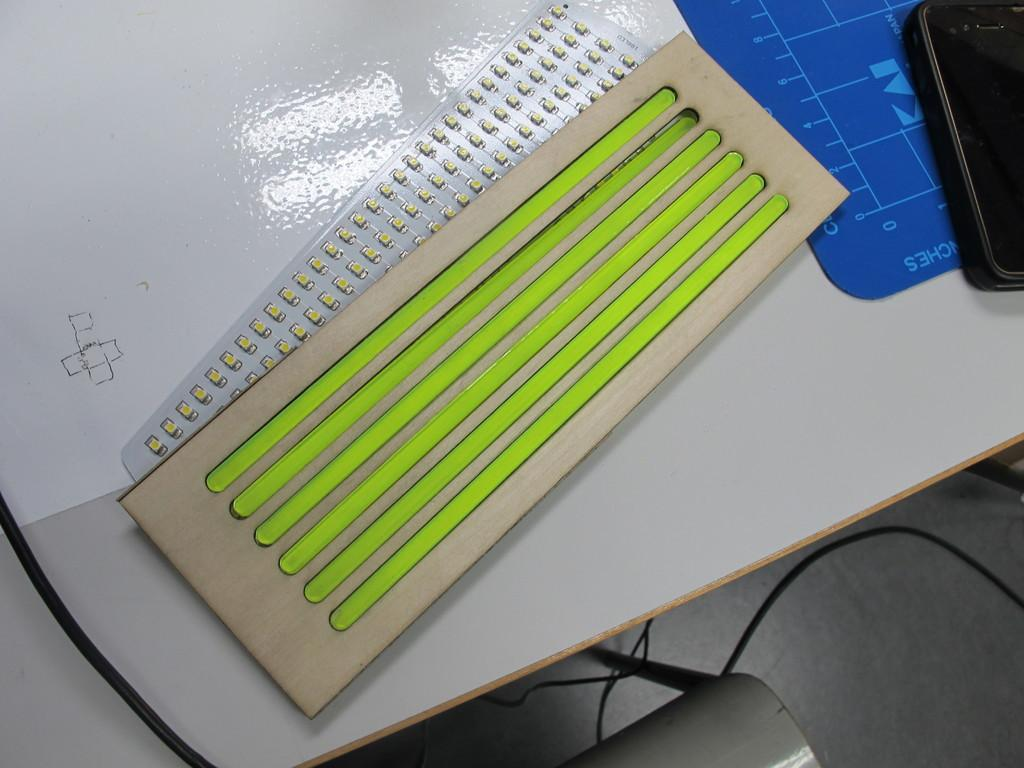What type of furniture is present in the image? There is a table in the image. What is placed on the table? Cardboard, an LED strip, a mouse pad, and a mobile are placed on the table. What might be used for illumination in the image? An: An LED strip is present on the table for illumination. What is visible at the bottom of the image? Wires are visible at the bottom of the image. What type of cap is being worn by the mouse pad in the image? There is no cap present in the image, as the mouse pad is an inanimate object and does not wear clothing. 